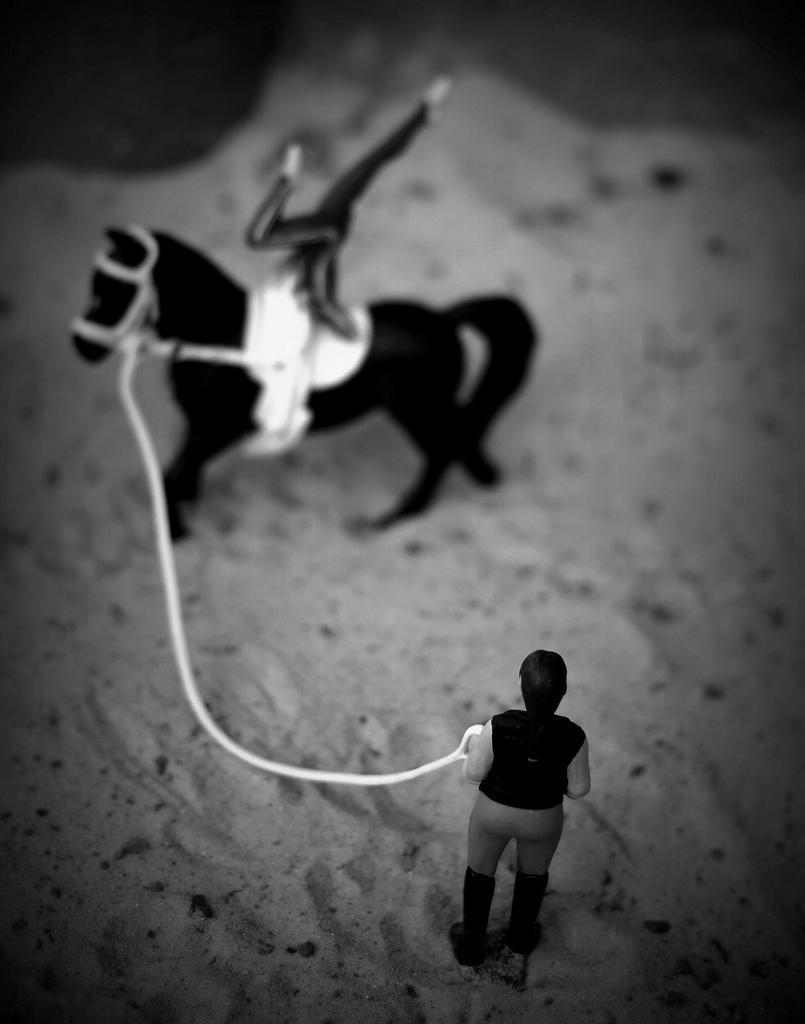How would you summarize this image in a sentence or two? As we can see in the image there is sand, black color toy horse and toy man holding a rope. 